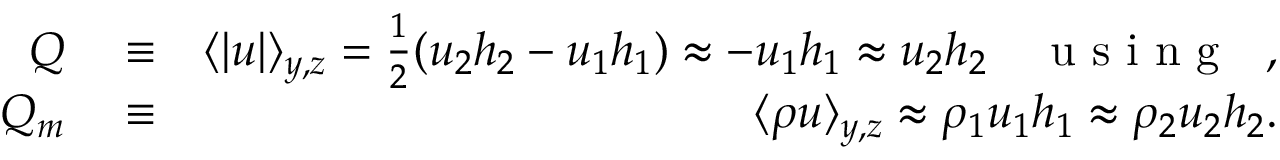<formula> <loc_0><loc_0><loc_500><loc_500>\begin{array} { r l r } { Q } & \equiv } & { \langle | u | \rangle _ { y , z } = \frac { 1 } { 2 } ( u _ { 2 } h _ { 2 } - u _ { 1 } h _ { 1 } ) \approx - u _ { 1 } h _ { 1 } \approx u _ { 2 } h _ { 2 } \quad u s i n g \ \ , } \\ { Q _ { m } } & \equiv } & { \langle \rho u \rangle _ { y , z } \approx \rho _ { 1 } u _ { 1 } h _ { 1 } \approx \rho _ { 2 } u _ { 2 } h _ { 2 } . } \end{array}</formula> 